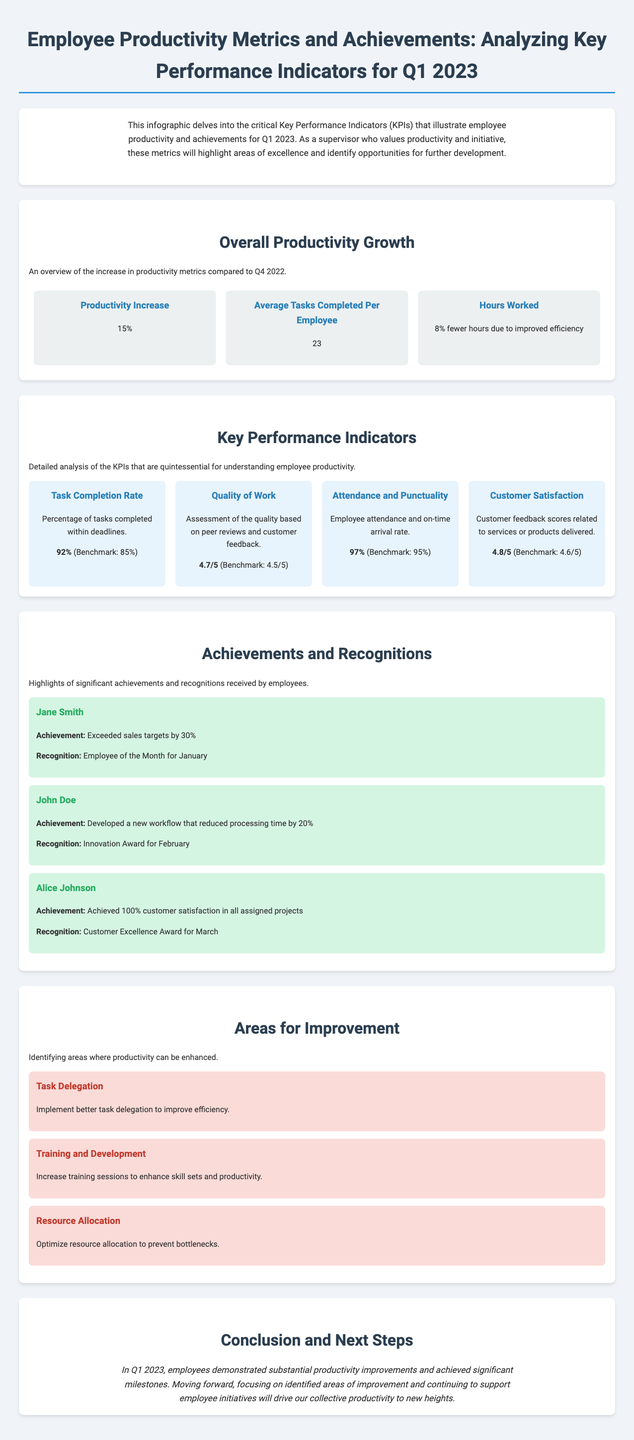What is the productivity increase compared to Q4 2022? The document states there is a 15% increase in productivity compared to Q4 2022.
Answer: 15% How many average tasks are completed per employee? The metric shows that the average number of tasks completed per employee is 23.
Answer: 23 What is the task completion rate percentage? The document indicates the task completion rate is 92%, which is above the benchmark of 85%.
Answer: 92% Who achieved Employee of the Month for January? According to the achievements section, Jane Smith was recognized as Employee of the Month for January.
Answer: Jane Smith What is the average quality of work score? The quality of work is assessed with a score of 4.7 out of 5, exceeding the benchmark of 4.5.
Answer: 4.7/5 Which area emphasizes the importance of increasing training sessions? The section identifies Training and Development as an area for improvement where enhancing skill sets is crucial.
Answer: Training and Development What recognition did John Doe receive in February? John Doe was awarded the Innovation Award for February for developing a new workflow.
Answer: Innovation Award What percentage represents the attendance and punctuality rate? The attendance and punctuality rate for employees is stated as 97%, exceeding the 95% benchmark.
Answer: 97% What is one identified area for improving productivity? The document lists Task Delegation as one area where improvement can increase efficiency.
Answer: Task Delegation 